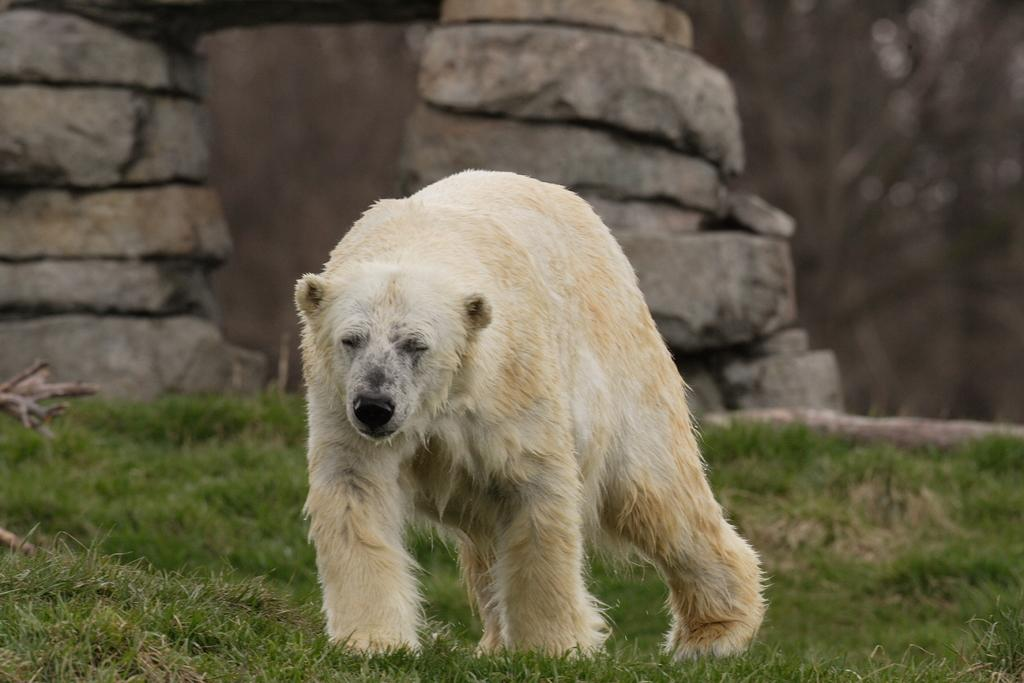What animal is present in the image? There is a polar bear in the image. What is the polar bear doing in the image? The polar bear is walking. What type of vegetation can be seen in the image? There is grass in the image. What can be seen in the background of the image? In the background, there are rocks placed one on top of the other. How does the polar bear express love to the cannon in the image? There is no cannon present in the image, and the polar bear does not express love as it is an animal and not capable of human emotions like love. 